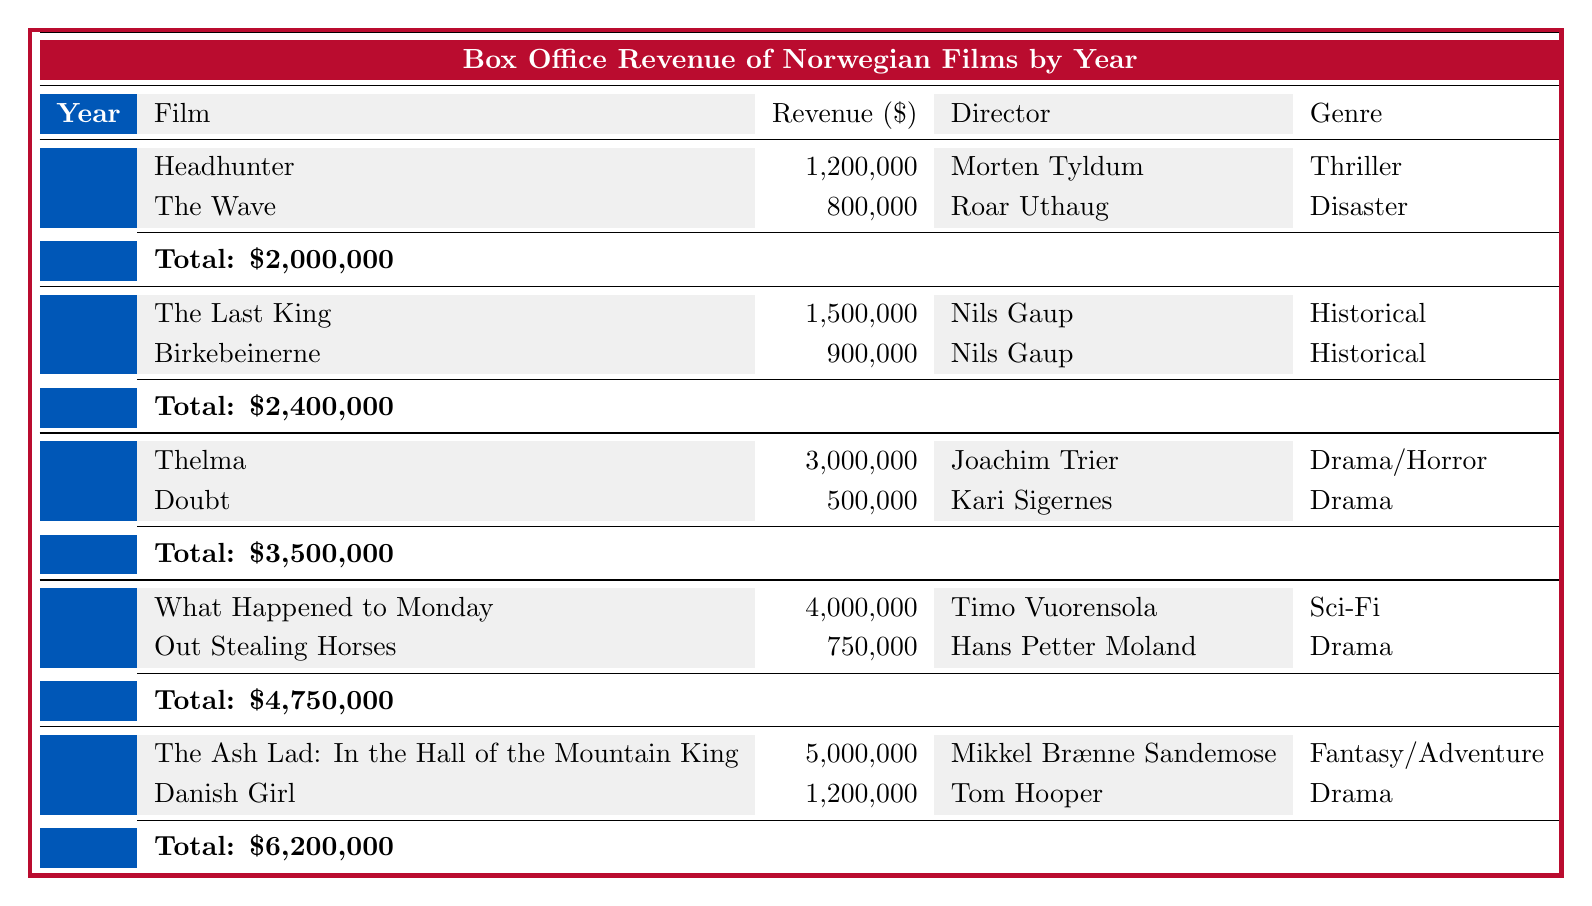What was the total revenue of Norwegian films in 2018? The total revenue for 2018 is clearly listed in the table as 4,750,000.
Answer: 4,750,000 Which film had the highest box office revenue in 2017? The table shows that in 2017, "Thelma" had the highest box office revenue of 3,000,000.
Answer: Thelma Did any films released in 2016 have box office revenue exceeding 1,000,000? In the table, it can be seen that "The Last King" had 1,500,000 and "Birkebeinerne" had 900,000. Therefore, only "The Last King" exceeded 1,000,000.
Answer: Yes What is the average box office revenue of films in 2019? The total revenue in 2019 was 6,200,000 from two films. To find the average, 6,200,000 divided by 2 equals 3,100,000.
Answer: 3,100,000 Which director had the most films represented in the table, and how many were there? By analyzing the films listed, Nils Gaup directed 3 films over the years (two in 2016 and one in 2017), making him the director with the most films represented.
Answer: Nils Gaup, 3 films Was the genre of the film with the highest box office revenue in 2018 a Sci-Fi? The highest box office revenue in 2018 was for "What Happened to Monday," which indeed falls under the Sci-Fi genre according to the table.
Answer: Yes What was the combined box office revenue of the films released in 2015? To calculate the combined revenue, I need to add the revenue of both films: 1,200,000 (Headhunter) + 800,000 (The Wave) = 2,000,000. This matches the total revenue reported for 2015 in the table.
Answer: 2,000,000 How much more revenue did films earn in 2019 compared to 2015? The revenue for 2019 is 6,200,000 and for 2015 it is 2,000,000. Subtracting gives 6,200,000 - 2,000,000 = 4,200,000, indicating that films in 2019 earned 4,200,000 more compared to 2015.
Answer: 4,200,000 